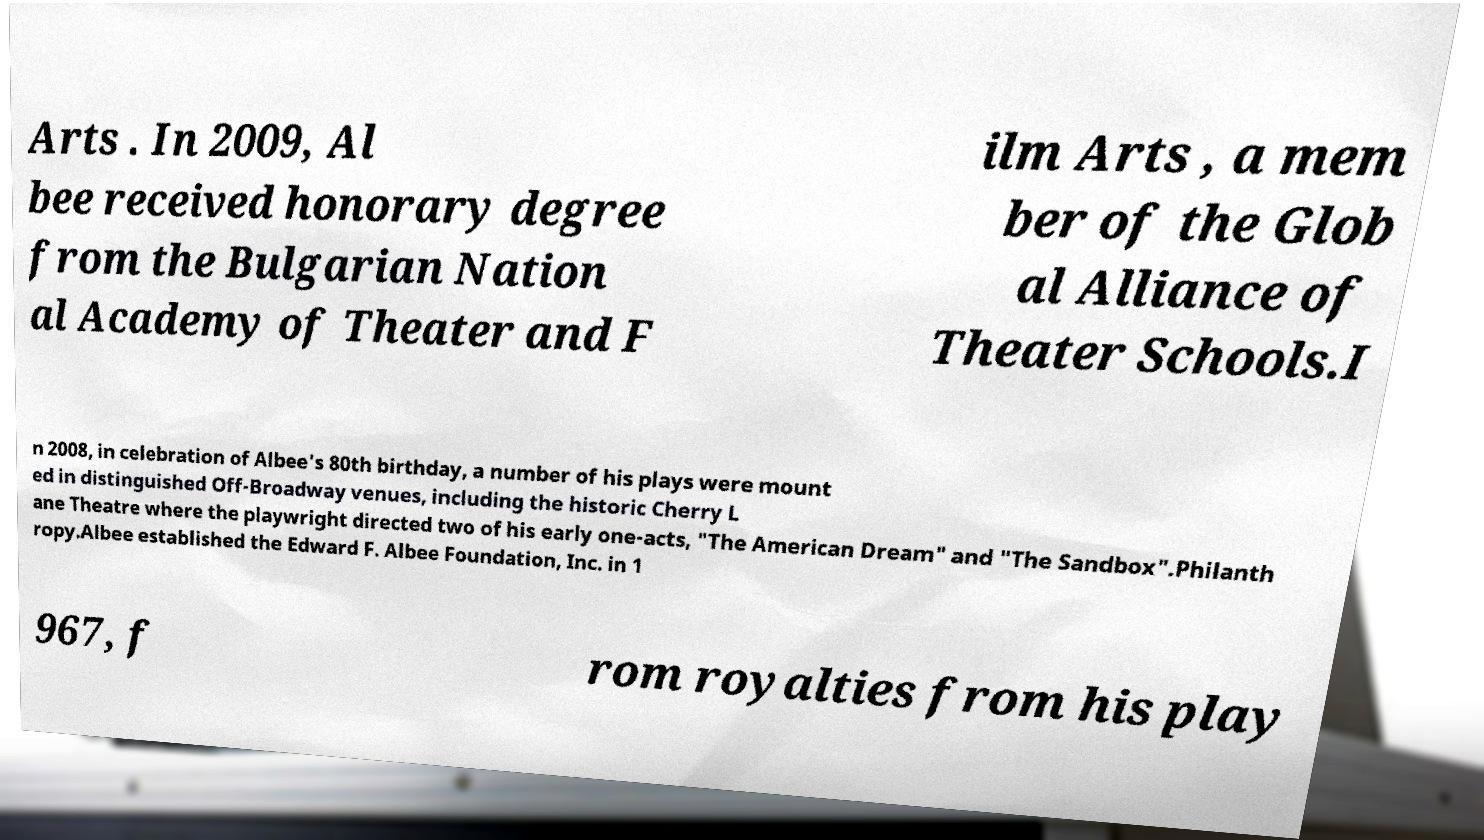Please read and relay the text visible in this image. What does it say? Arts . In 2009, Al bee received honorary degree from the Bulgarian Nation al Academy of Theater and F ilm Arts , a mem ber of the Glob al Alliance of Theater Schools.I n 2008, in celebration of Albee's 80th birthday, a number of his plays were mount ed in distinguished Off-Broadway venues, including the historic Cherry L ane Theatre where the playwright directed two of his early one-acts, "The American Dream" and "The Sandbox".Philanth ropy.Albee established the Edward F. Albee Foundation, Inc. in 1 967, f rom royalties from his play 